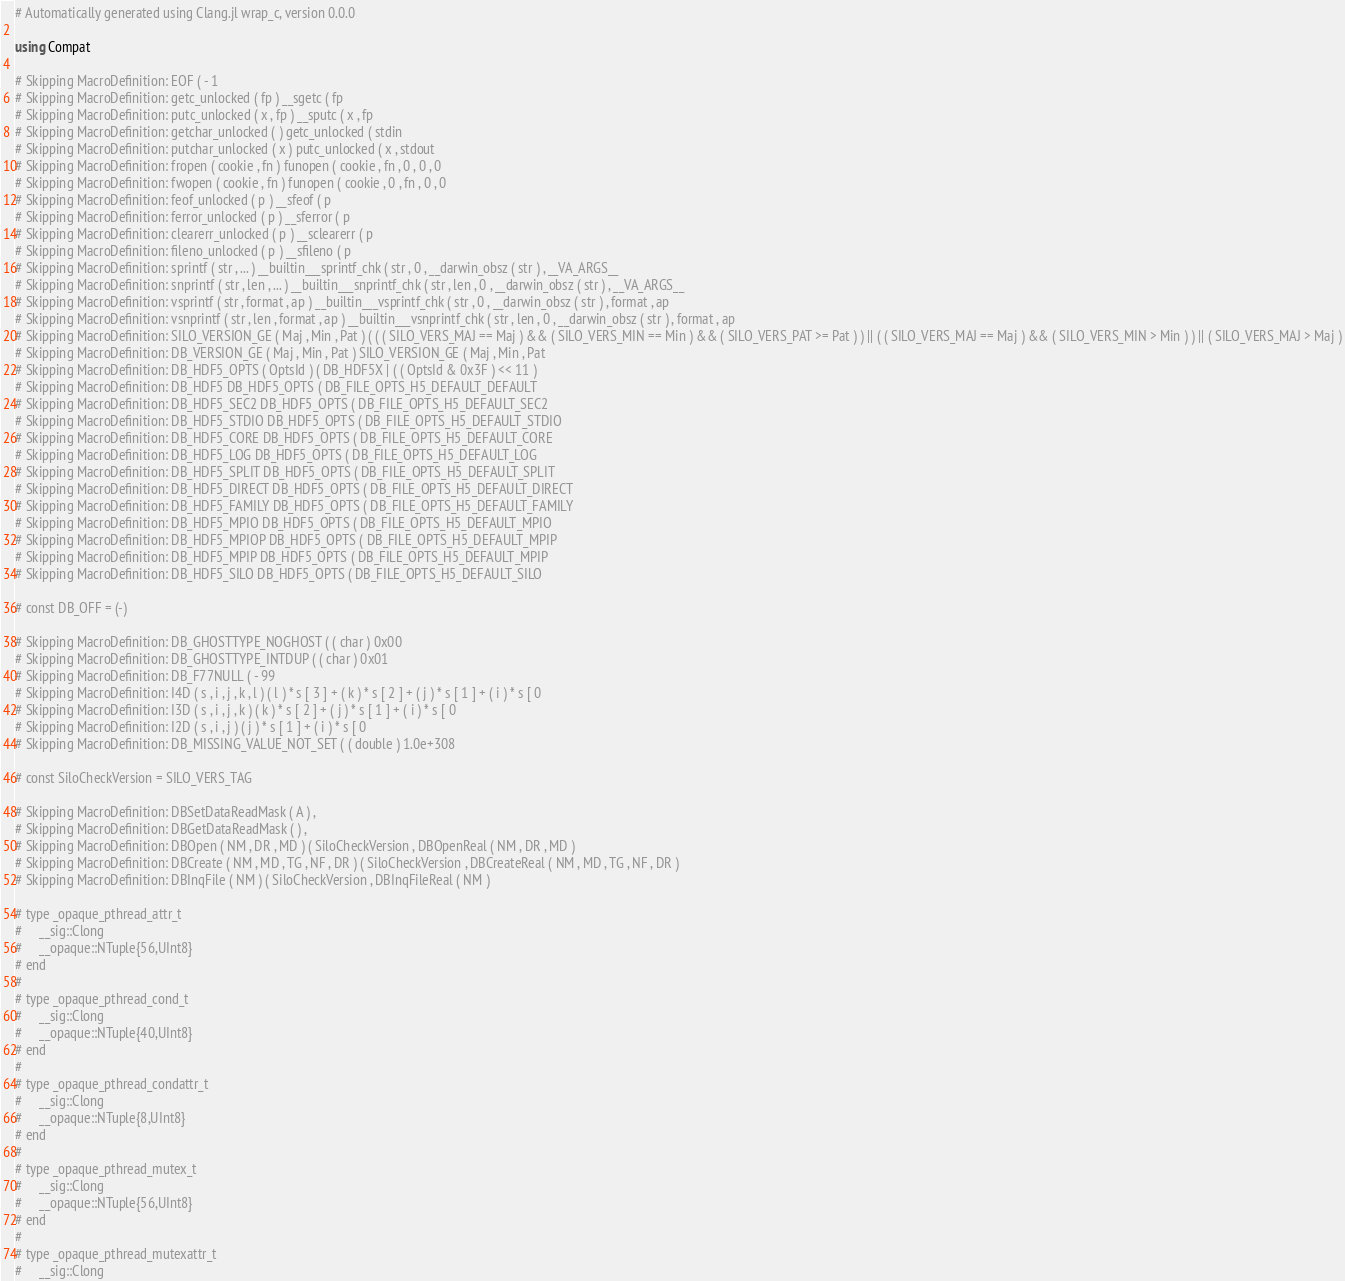<code> <loc_0><loc_0><loc_500><loc_500><_Julia_># Automatically generated using Clang.jl wrap_c, version 0.0.0

using Compat

# Skipping MacroDefinition: EOF ( - 1
# Skipping MacroDefinition: getc_unlocked ( fp ) __sgetc ( fp
# Skipping MacroDefinition: putc_unlocked ( x , fp ) __sputc ( x , fp
# Skipping MacroDefinition: getchar_unlocked ( ) getc_unlocked ( stdin
# Skipping MacroDefinition: putchar_unlocked ( x ) putc_unlocked ( x , stdout
# Skipping MacroDefinition: fropen ( cookie , fn ) funopen ( cookie , fn , 0 , 0 , 0
# Skipping MacroDefinition: fwopen ( cookie , fn ) funopen ( cookie , 0 , fn , 0 , 0
# Skipping MacroDefinition: feof_unlocked ( p ) __sfeof ( p
# Skipping MacroDefinition: ferror_unlocked ( p ) __sferror ( p
# Skipping MacroDefinition: clearerr_unlocked ( p ) __sclearerr ( p
# Skipping MacroDefinition: fileno_unlocked ( p ) __sfileno ( p
# Skipping MacroDefinition: sprintf ( str , ... ) __builtin___sprintf_chk ( str , 0 , __darwin_obsz ( str ) , __VA_ARGS__
# Skipping MacroDefinition: snprintf ( str , len , ... ) __builtin___snprintf_chk ( str , len , 0 , __darwin_obsz ( str ) , __VA_ARGS__
# Skipping MacroDefinition: vsprintf ( str , format , ap ) __builtin___vsprintf_chk ( str , 0 , __darwin_obsz ( str ) , format , ap
# Skipping MacroDefinition: vsnprintf ( str , len , format , ap ) __builtin___vsnprintf_chk ( str , len , 0 , __darwin_obsz ( str ) , format , ap
# Skipping MacroDefinition: SILO_VERSION_GE ( Maj , Min , Pat ) ( ( ( SILO_VERS_MAJ == Maj ) && ( SILO_VERS_MIN == Min ) && ( SILO_VERS_PAT >= Pat ) ) || ( ( SILO_VERS_MAJ == Maj ) && ( SILO_VERS_MIN > Min ) ) || ( SILO_VERS_MAJ > Maj )
# Skipping MacroDefinition: DB_VERSION_GE ( Maj , Min , Pat ) SILO_VERSION_GE ( Maj , Min , Pat
# Skipping MacroDefinition: DB_HDF5_OPTS ( OptsId ) ( DB_HDF5X | ( ( OptsId & 0x3F ) << 11 )
# Skipping MacroDefinition: DB_HDF5 DB_HDF5_OPTS ( DB_FILE_OPTS_H5_DEFAULT_DEFAULT
# Skipping MacroDefinition: DB_HDF5_SEC2 DB_HDF5_OPTS ( DB_FILE_OPTS_H5_DEFAULT_SEC2
# Skipping MacroDefinition: DB_HDF5_STDIO DB_HDF5_OPTS ( DB_FILE_OPTS_H5_DEFAULT_STDIO
# Skipping MacroDefinition: DB_HDF5_CORE DB_HDF5_OPTS ( DB_FILE_OPTS_H5_DEFAULT_CORE
# Skipping MacroDefinition: DB_HDF5_LOG DB_HDF5_OPTS ( DB_FILE_OPTS_H5_DEFAULT_LOG
# Skipping MacroDefinition: DB_HDF5_SPLIT DB_HDF5_OPTS ( DB_FILE_OPTS_H5_DEFAULT_SPLIT
# Skipping MacroDefinition: DB_HDF5_DIRECT DB_HDF5_OPTS ( DB_FILE_OPTS_H5_DEFAULT_DIRECT
# Skipping MacroDefinition: DB_HDF5_FAMILY DB_HDF5_OPTS ( DB_FILE_OPTS_H5_DEFAULT_FAMILY
# Skipping MacroDefinition: DB_HDF5_MPIO DB_HDF5_OPTS ( DB_FILE_OPTS_H5_DEFAULT_MPIO
# Skipping MacroDefinition: DB_HDF5_MPIOP DB_HDF5_OPTS ( DB_FILE_OPTS_H5_DEFAULT_MPIP
# Skipping MacroDefinition: DB_HDF5_MPIP DB_HDF5_OPTS ( DB_FILE_OPTS_H5_DEFAULT_MPIP
# Skipping MacroDefinition: DB_HDF5_SILO DB_HDF5_OPTS ( DB_FILE_OPTS_H5_DEFAULT_SILO

# const DB_OFF = (-)

# Skipping MacroDefinition: DB_GHOSTTYPE_NOGHOST ( ( char ) 0x00
# Skipping MacroDefinition: DB_GHOSTTYPE_INTDUP ( ( char ) 0x01
# Skipping MacroDefinition: DB_F77NULL ( - 99
# Skipping MacroDefinition: I4D ( s , i , j , k , l ) ( l ) * s [ 3 ] + ( k ) * s [ 2 ] + ( j ) * s [ 1 ] + ( i ) * s [ 0
# Skipping MacroDefinition: I3D ( s , i , j , k ) ( k ) * s [ 2 ] + ( j ) * s [ 1 ] + ( i ) * s [ 0
# Skipping MacroDefinition: I2D ( s , i , j ) ( j ) * s [ 1 ] + ( i ) * s [ 0
# Skipping MacroDefinition: DB_MISSING_VALUE_NOT_SET ( ( double ) 1.0e+308

# const SiloCheckVersion = SILO_VERS_TAG

# Skipping MacroDefinition: DBSetDataReadMask ( A ) ,
# Skipping MacroDefinition: DBGetDataReadMask ( ) ,
# Skipping MacroDefinition: DBOpen ( NM , DR , MD ) ( SiloCheckVersion , DBOpenReal ( NM , DR , MD )
# Skipping MacroDefinition: DBCreate ( NM , MD , TG , NF , DR ) ( SiloCheckVersion , DBCreateReal ( NM , MD , TG , NF , DR )
# Skipping MacroDefinition: DBInqFile ( NM ) ( SiloCheckVersion , DBInqFileReal ( NM )

# type _opaque_pthread_attr_t
#     __sig::Clong
#     __opaque::NTuple{56,UInt8}
# end
#
# type _opaque_pthread_cond_t
#     __sig::Clong
#     __opaque::NTuple{40,UInt8}
# end
#
# type _opaque_pthread_condattr_t
#     __sig::Clong
#     __opaque::NTuple{8,UInt8}
# end
#
# type _opaque_pthread_mutex_t
#     __sig::Clong
#     __opaque::NTuple{56,UInt8}
# end
#
# type _opaque_pthread_mutexattr_t
#     __sig::Clong</code> 